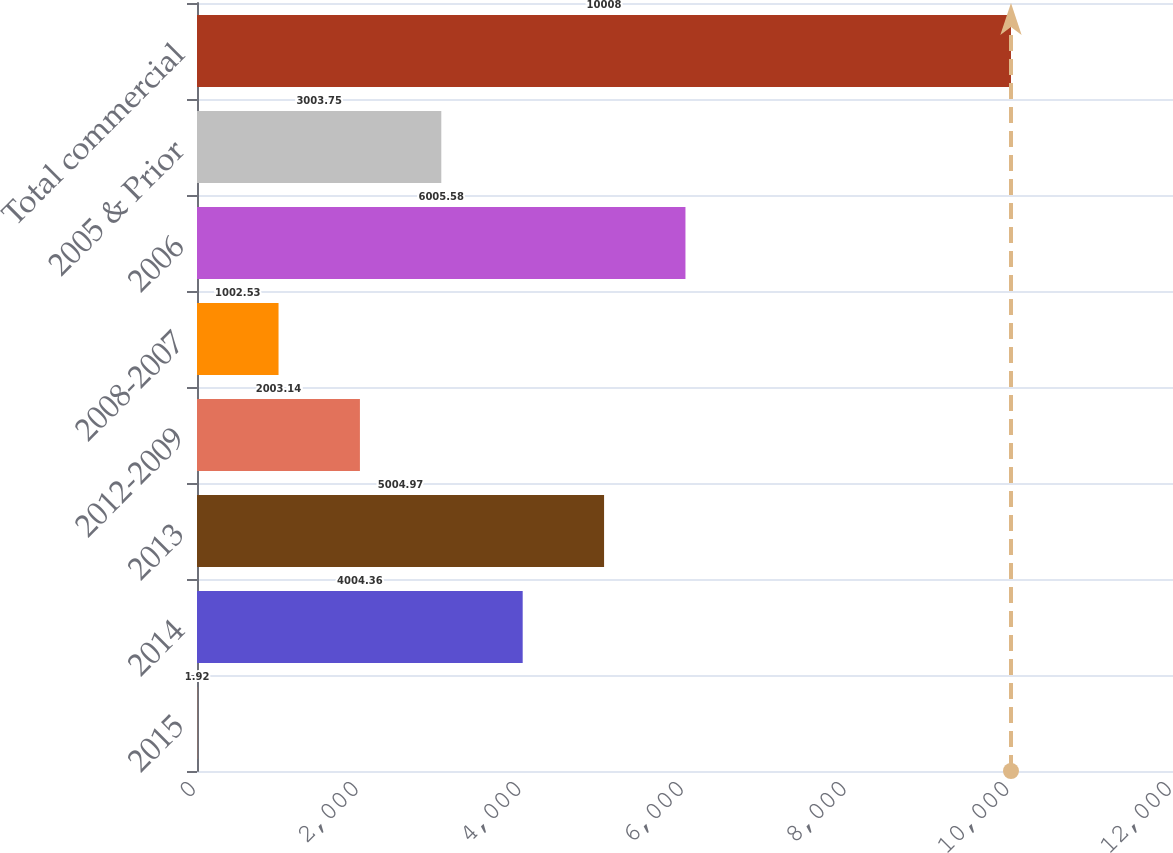Convert chart to OTSL. <chart><loc_0><loc_0><loc_500><loc_500><bar_chart><fcel>2015<fcel>2014<fcel>2013<fcel>2012-2009<fcel>2008-2007<fcel>2006<fcel>2005 & Prior<fcel>Total commercial<nl><fcel>1.92<fcel>4004.36<fcel>5004.97<fcel>2003.14<fcel>1002.53<fcel>6005.58<fcel>3003.75<fcel>10008<nl></chart> 